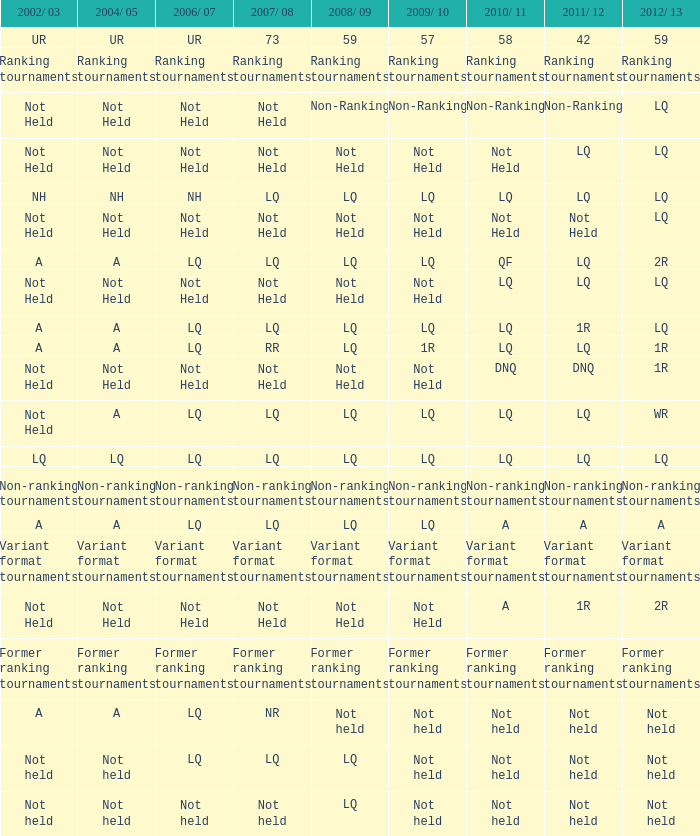Help me parse the entirety of this table. {'header': ['2002/ 03', '2004/ 05', '2006/ 07', '2007/ 08', '2008/ 09', '2009/ 10', '2010/ 11', '2011/ 12', '2012/ 13'], 'rows': [['UR', 'UR', 'UR', '73', '59', '57', '58', '42', '59'], ['Ranking tournaments', 'Ranking tournaments', 'Ranking tournaments', 'Ranking tournaments', 'Ranking tournaments', 'Ranking tournaments', 'Ranking tournaments', 'Ranking tournaments', 'Ranking tournaments'], ['Not Held', 'Not Held', 'Not Held', 'Not Held', 'Non-Ranking', 'Non-Ranking', 'Non-Ranking', 'Non-Ranking', 'LQ'], ['Not Held', 'Not Held', 'Not Held', 'Not Held', 'Not Held', 'Not Held', 'Not Held', 'LQ', 'LQ'], ['NH', 'NH', 'NH', 'LQ', 'LQ', 'LQ', 'LQ', 'LQ', 'LQ'], ['Not Held', 'Not Held', 'Not Held', 'Not Held', 'Not Held', 'Not Held', 'Not Held', 'Not Held', 'LQ'], ['A', 'A', 'LQ', 'LQ', 'LQ', 'LQ', 'QF', 'LQ', '2R'], ['Not Held', 'Not Held', 'Not Held', 'Not Held', 'Not Held', 'Not Held', 'LQ', 'LQ', 'LQ'], ['A', 'A', 'LQ', 'LQ', 'LQ', 'LQ', 'LQ', '1R', 'LQ'], ['A', 'A', 'LQ', 'RR', 'LQ', '1R', 'LQ', 'LQ', '1R'], ['Not Held', 'Not Held', 'Not Held', 'Not Held', 'Not Held', 'Not Held', 'DNQ', 'DNQ', '1R'], ['Not Held', 'A', 'LQ', 'LQ', 'LQ', 'LQ', 'LQ', 'LQ', 'WR'], ['LQ', 'LQ', 'LQ', 'LQ', 'LQ', 'LQ', 'LQ', 'LQ', 'LQ'], ['Non-ranking tournaments', 'Non-ranking tournaments', 'Non-ranking tournaments', 'Non-ranking tournaments', 'Non-ranking tournaments', 'Non-ranking tournaments', 'Non-ranking tournaments', 'Non-ranking tournaments', 'Non-ranking tournaments'], ['A', 'A', 'LQ', 'LQ', 'LQ', 'LQ', 'A', 'A', 'A'], ['Variant format tournaments', 'Variant format tournaments', 'Variant format tournaments', 'Variant format tournaments', 'Variant format tournaments', 'Variant format tournaments', 'Variant format tournaments', 'Variant format tournaments', 'Variant format tournaments'], ['Not Held', 'Not Held', 'Not Held', 'Not Held', 'Not Held', 'Not Held', 'A', '1R', '2R'], ['Former ranking tournaments', 'Former ranking tournaments', 'Former ranking tournaments', 'Former ranking tournaments', 'Former ranking tournaments', 'Former ranking tournaments', 'Former ranking tournaments', 'Former ranking tournaments', 'Former ranking tournaments'], ['A', 'A', 'LQ', 'NR', 'Not held', 'Not held', 'Not held', 'Not held', 'Not held'], ['Not held', 'Not held', 'LQ', 'LQ', 'LQ', 'Not held', 'Not held', 'Not held', 'Not held'], ['Not held', 'Not held', 'Not held', 'Not held', 'LQ', 'Not held', 'Not held', 'Not held', 'Not held']]} Name the 2009/10 with 2011/12 of lq and 2008/09 of not held Not Held, Not Held. 